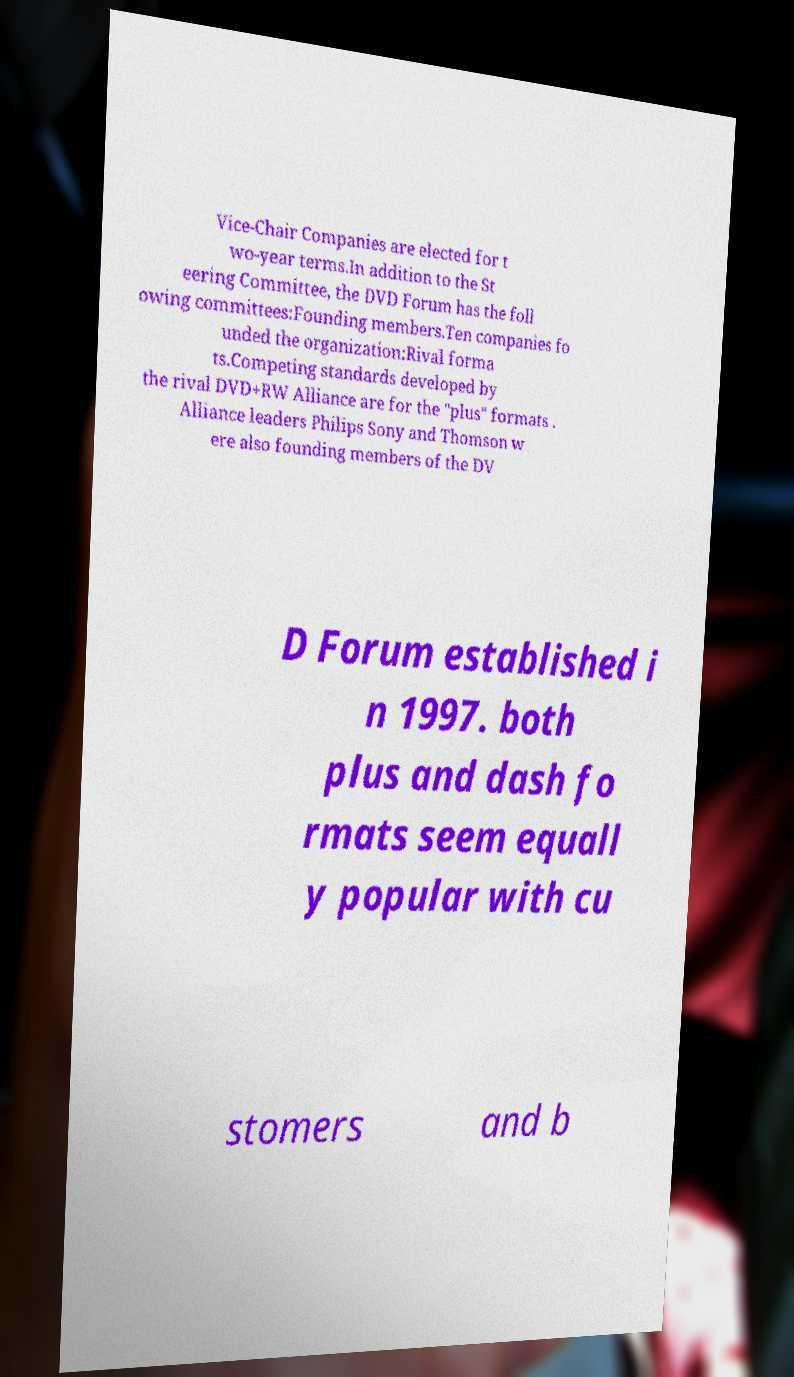Please identify and transcribe the text found in this image. Vice-Chair Companies are elected for t wo-year terms.In addition to the St eering Committee, the DVD Forum has the foll owing committees:Founding members.Ten companies fo unded the organization:Rival forma ts.Competing standards developed by the rival DVD+RW Alliance are for the "plus" formats . Alliance leaders Philips Sony and Thomson w ere also founding members of the DV D Forum established i n 1997. both plus and dash fo rmats seem equall y popular with cu stomers and b 